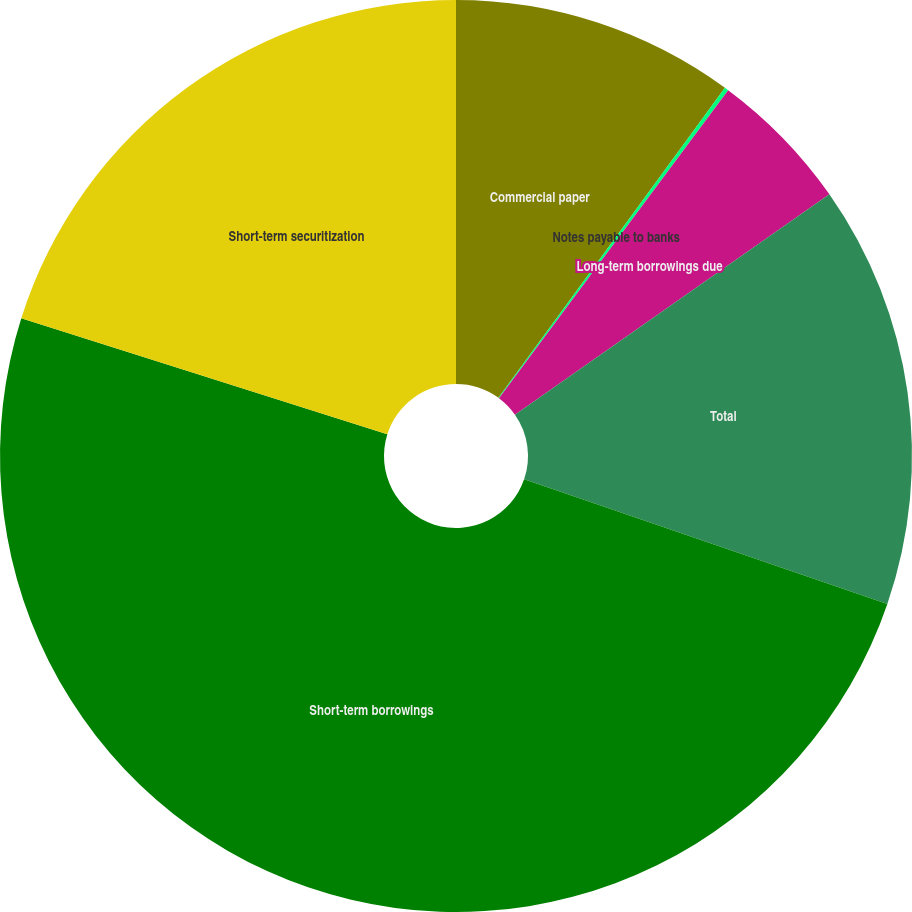<chart> <loc_0><loc_0><loc_500><loc_500><pie_chart><fcel>Commercial paper<fcel>Notes payable to banks<fcel>Long-term borrowings due<fcel>Total<fcel>Short-term borrowings<fcel>Short-term securitization<nl><fcel>10.04%<fcel>0.14%<fcel>5.09%<fcel>14.99%<fcel>49.63%<fcel>20.12%<nl></chart> 